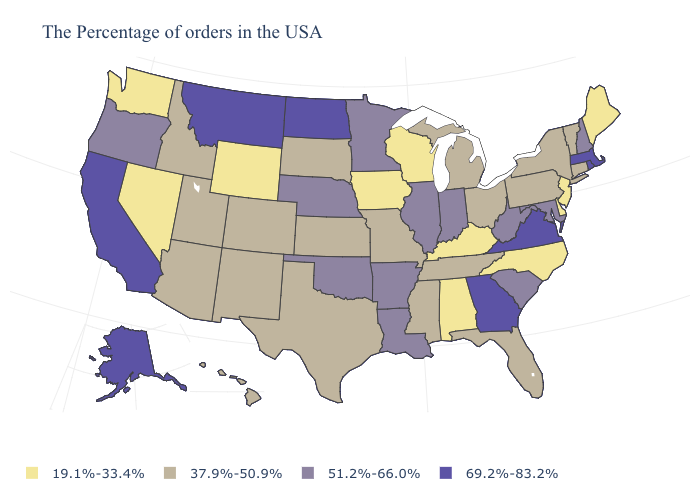Name the states that have a value in the range 51.2%-66.0%?
Short answer required. New Hampshire, Maryland, South Carolina, West Virginia, Indiana, Illinois, Louisiana, Arkansas, Minnesota, Nebraska, Oklahoma, Oregon. Among the states that border North Carolina , which have the lowest value?
Answer briefly. Tennessee. Name the states that have a value in the range 69.2%-83.2%?
Write a very short answer. Massachusetts, Rhode Island, Virginia, Georgia, North Dakota, Montana, California, Alaska. Which states have the lowest value in the West?
Be succinct. Wyoming, Nevada, Washington. Name the states that have a value in the range 69.2%-83.2%?
Keep it brief. Massachusetts, Rhode Island, Virginia, Georgia, North Dakota, Montana, California, Alaska. Among the states that border California , does Arizona have the lowest value?
Short answer required. No. What is the highest value in the MidWest ?
Answer briefly. 69.2%-83.2%. Does the first symbol in the legend represent the smallest category?
Keep it brief. Yes. What is the value of Louisiana?
Be succinct. 51.2%-66.0%. What is the value of Florida?
Keep it brief. 37.9%-50.9%. Which states have the lowest value in the West?
Be succinct. Wyoming, Nevada, Washington. What is the highest value in the West ?
Give a very brief answer. 69.2%-83.2%. What is the highest value in the Northeast ?
Give a very brief answer. 69.2%-83.2%. How many symbols are there in the legend?
Write a very short answer. 4. What is the lowest value in states that border New Jersey?
Keep it brief. 19.1%-33.4%. 